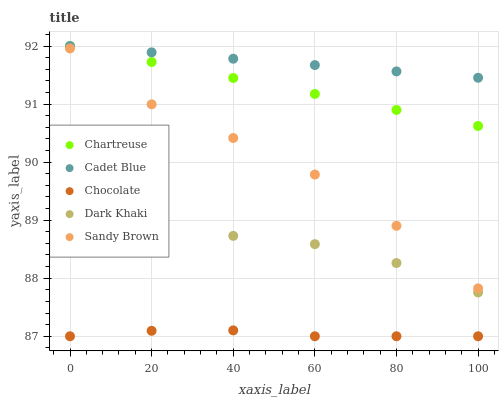Does Chocolate have the minimum area under the curve?
Answer yes or no. Yes. Does Cadet Blue have the maximum area under the curve?
Answer yes or no. Yes. Does Chartreuse have the minimum area under the curve?
Answer yes or no. No. Does Chartreuse have the maximum area under the curve?
Answer yes or no. No. Is Chartreuse the smoothest?
Answer yes or no. Yes. Is Sandy Brown the roughest?
Answer yes or no. Yes. Is Sandy Brown the smoothest?
Answer yes or no. No. Is Cadet Blue the roughest?
Answer yes or no. No. Does Chocolate have the lowest value?
Answer yes or no. Yes. Does Chartreuse have the lowest value?
Answer yes or no. No. Does Cadet Blue have the highest value?
Answer yes or no. Yes. Does Sandy Brown have the highest value?
Answer yes or no. No. Is Chocolate less than Dark Khaki?
Answer yes or no. Yes. Is Chartreuse greater than Sandy Brown?
Answer yes or no. Yes. Does Chartreuse intersect Cadet Blue?
Answer yes or no. Yes. Is Chartreuse less than Cadet Blue?
Answer yes or no. No. Is Chartreuse greater than Cadet Blue?
Answer yes or no. No. Does Chocolate intersect Dark Khaki?
Answer yes or no. No. 